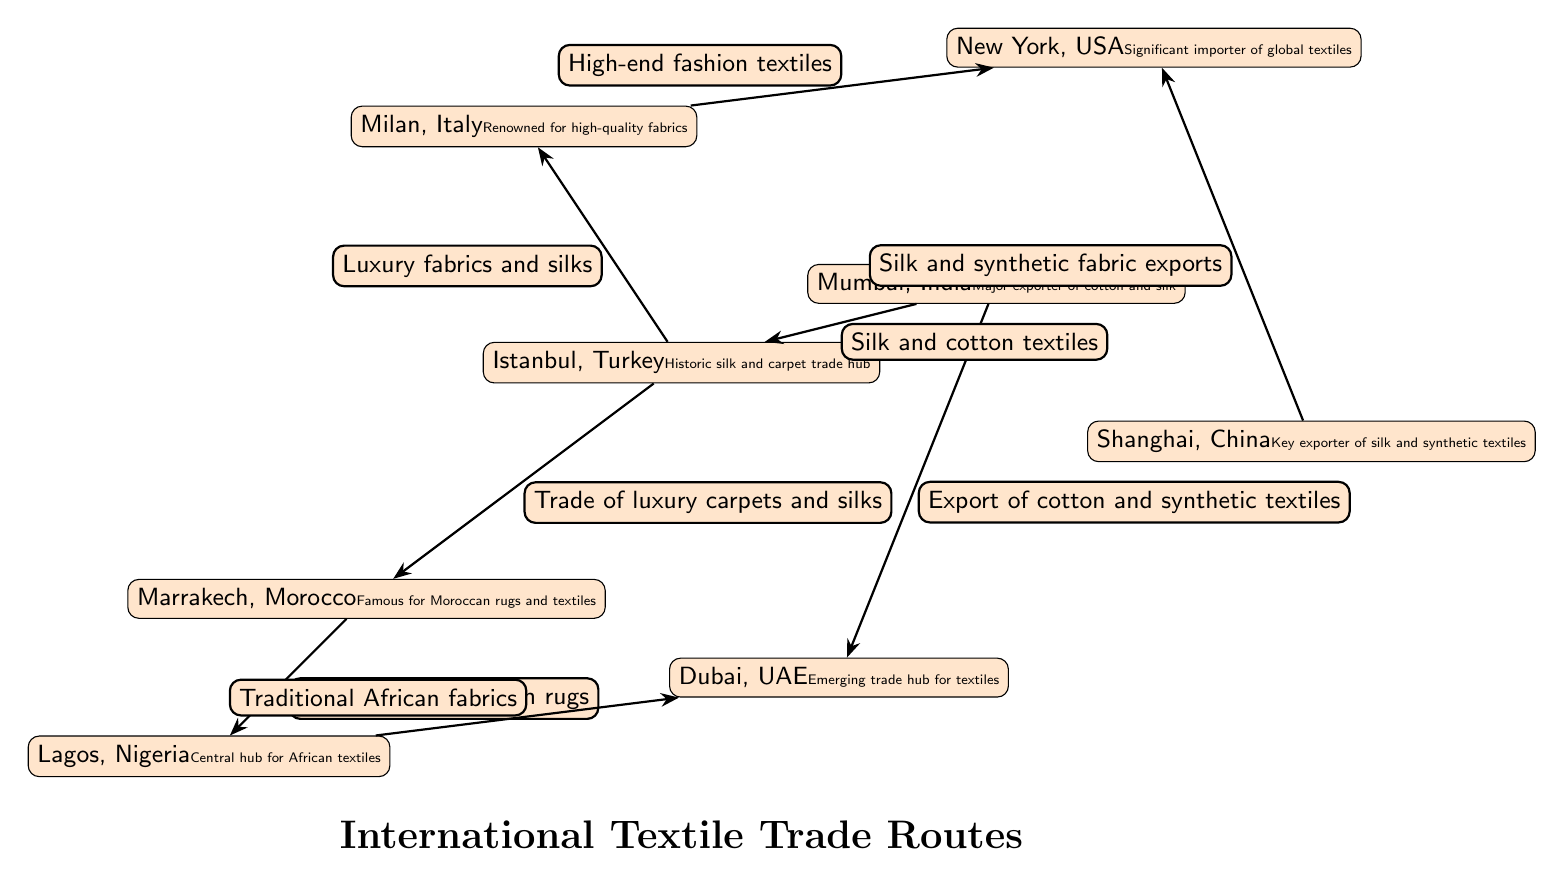What is the main export from Mumbai? The diagram indicates that Mumbai exports "cotton and silk" textiles, as denoted by the edge label connecting Mumbai to Dubai.
Answer: cotton and silk Which city is known for its traditional African fabrics? The diagram shows that Lagos is indicated as a central hub for African textiles, specifically mentioning "Traditional African fabrics" along the edge to Dubai.
Answer: Lagos How many key export/import hubs are identified in the diagram? By counting the nodes in the diagram, we see there are 8 unique hubs (Istanbul, Marrakech, Mumbai, Shanghai, Milan, New York, Dubai, Lagos).
Answer: 8 What does the arrow from Istanbul to Milan represent? The edge from Istanbul to Milan is labeled "Luxury fabrics and silks," which signifies the type of trade relationship between these two cities.
Answer: Luxury fabrics and silks Which two locations are linked by a trade of luxury carpets and silks? The edge connecting Istanbul to Marrakech specifies "Trade of luxury carpets and silks," clearly stating the relationship between these two cities.
Answer: Istanbul and Marrakech What textile does Shanghai primarily export to New York? The diagram indicates that Shanghai exports "Silk and synthetic fabric" to New York, as shown on the corresponding edge.
Answer: Silk and synthetic fabric Which city is identified as the significant importer of global textiles? New York is labeled in the diagram as a "Significant importer of global textiles," specifically denoting its role in the international textile trade.
Answer: New York What type of textiles does Dubai emerge as a hub for? The diagram describes Dubai as an "Emerging trade hub for textiles," suggesting its growing role in the textile market, without specifying a particular type but indicating its importance in trade.
Answer: textiles 